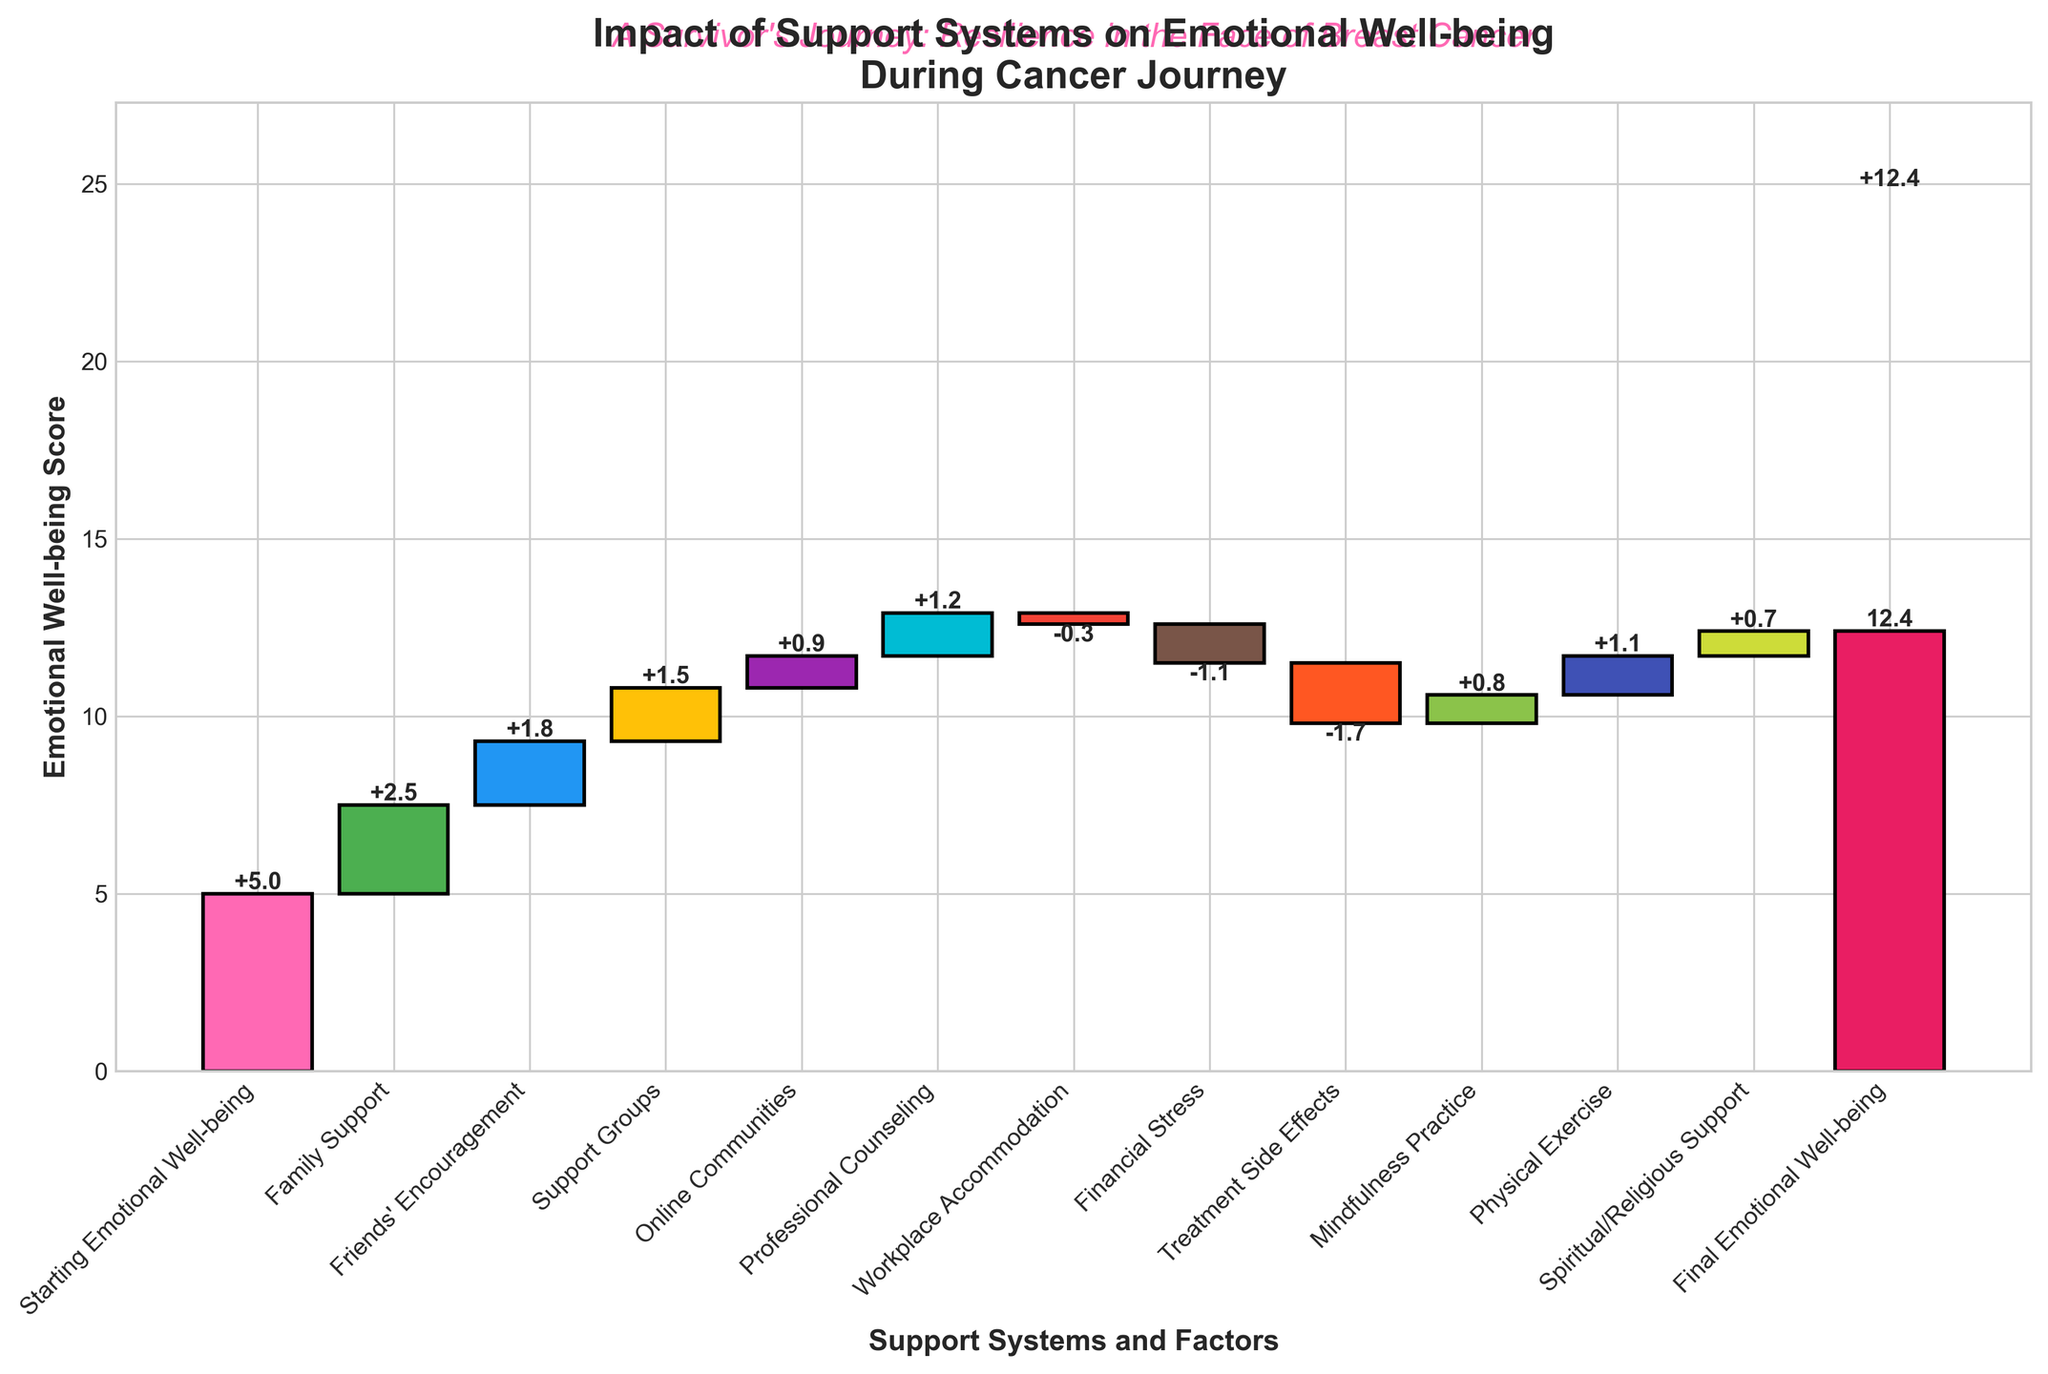What is the title of the chart? The title of the chart is displayed prominently at the top of the figure. It reads "Impact of Support Systems on Emotional Well-being During Cancer Journey".
Answer: Impact of Support Systems on Emotional Well-being During Cancer Journey What is the initial emotional well-being score? The starting emotional well-being score is labeled as "Starting Emotional Well-being" in the first bar of the chart. The numerical value next to this bar is 5.
Answer: 5 Which support system contributed the most positively to emotional well-being? From the bars visualized on the chart, "Family Support" has the highest positive value among all contributions, marked as +2.5.
Answer: Family Support How much did financial stress impact emotional well-being? Identify the bar labeled "Financial Stress". The corresponding value next to this bar indicates its impact, which is -1.1.
Answer: -1.1 What is the final emotional well-being score? The last bar on the chart represents the final emotional well-being score, labeled "Final Emotional Well-being" with the numerical value next to it being 12.4.
Answer: 12.4 What is the net change in emotional well-being from the start to the end? To find the net change, subtract the starting emotional well-being score from the final score. Thus, 12.4 - 5 = 7.4.
Answer: 7.4 Which factor had a negative impact but still had the least magnitude? Examine the negative bars, comparing their values. "Workplace Accommodation" has the smallest negative impact with a value of -0.3.
Answer: Workplace Accommodation How much does professional counseling contribute to emotional well-being? Locate the bar titled "Professional Counseling" on the chart. The value corresponding to this bar indicates its contribution, which is +1.2.
Answer: +1.2 Which support system has a greater positive impact: Friends' Encouragement or Physical Exercise? Compare the bars labeled "Friends' Encouragement" and "Physical Exercise". "Friends' Encouragement" has a value of +1.8 while "Physical Exercise" has +1.1. Therefore, Friends' Encouragement has a greater positive impact.
Answer: Friends' Encouragement Considering only the positive contributions, what is the total improvement in emotional well-being? Add up all the positive values: Family Support (+2.5), Friends' Encouragement (+1.8), Support Groups (+1.5), Online Communities (+0.9), Professional Counseling (+1.2), Mindfulness Practice (+0.8), Physical Exercise (+1.1), and Spiritual/Religious Support (+0.7). Total improvement = 2.5 + 1.8 + 1.5 + 0.9 + 1.2 + 0.8 + 1.1 + 0.7 = 10.5.
Answer: 10.5 